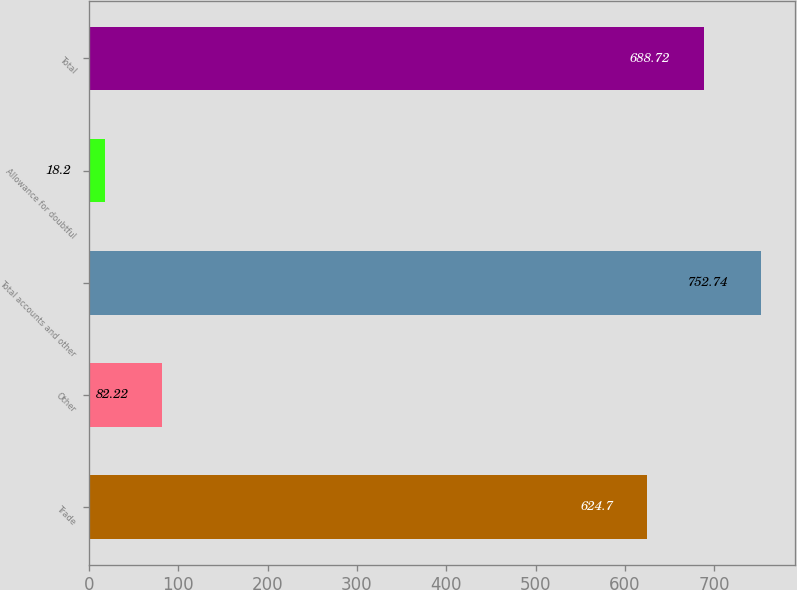Convert chart to OTSL. <chart><loc_0><loc_0><loc_500><loc_500><bar_chart><fcel>Trade<fcel>Other<fcel>Total accounts and other<fcel>Allowance for doubtful<fcel>Total<nl><fcel>624.7<fcel>82.22<fcel>752.74<fcel>18.2<fcel>688.72<nl></chart> 